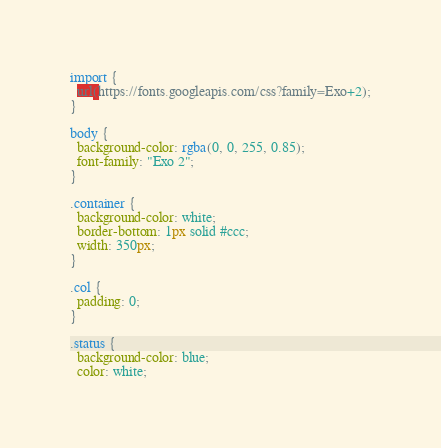<code> <loc_0><loc_0><loc_500><loc_500><_CSS_>import {
  url(https://fonts.googleapis.com/css?family=Exo+2);
}

body {
  background-color: rgba(0, 0, 255, 0.85);
  font-family: "Exo 2";
}

.container {
  background-color: white;
  border-bottom: 1px solid #ccc;
  width: 350px;
}

.col {
  padding: 0;
}

.status {
  background-color: blue;
  color: white;</code> 